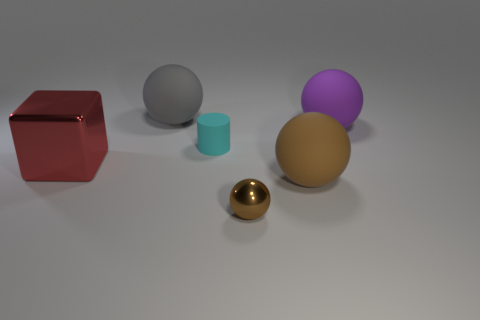What is the shape of the purple rubber object?
Provide a succinct answer. Sphere. What number of other objects are the same material as the block?
Make the answer very short. 1. Do the gray ball and the cyan object have the same size?
Provide a short and direct response. No. What is the shape of the metal object behind the brown rubber object?
Make the answer very short. Cube. There is a shiny object that is in front of the object on the left side of the large gray sphere; what is its color?
Provide a short and direct response. Brown. Is the shape of the large object that is in front of the red object the same as the big matte object that is left of the small brown sphere?
Provide a succinct answer. Yes. There is a brown object that is the same size as the cyan rubber object; what is its shape?
Your answer should be compact. Sphere. There is a cylinder that is the same material as the gray sphere; what color is it?
Your answer should be compact. Cyan. There is a large brown object; is its shape the same as the shiny thing left of the tiny metallic sphere?
Ensure brevity in your answer.  No. What material is the other sphere that is the same color as the small ball?
Give a very brief answer. Rubber. 